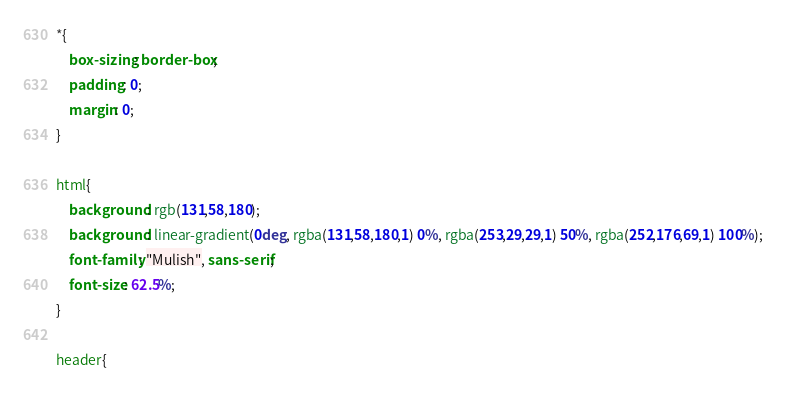<code> <loc_0><loc_0><loc_500><loc_500><_CSS_>*{
    box-sizing: border-box;
    padding: 0;
    margin: 0;  
}

html{
    background: rgb(131,58,180);
    background: linear-gradient(0deg, rgba(131,58,180,1) 0%, rgba(253,29,29,1) 50%, rgba(252,176,69,1) 100%);
    font-family: "Mulish", sans-serif;
    font-size: 62.5%;
}

header{</code> 